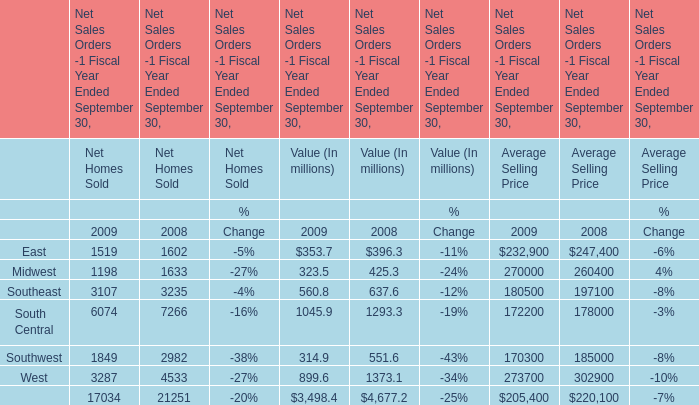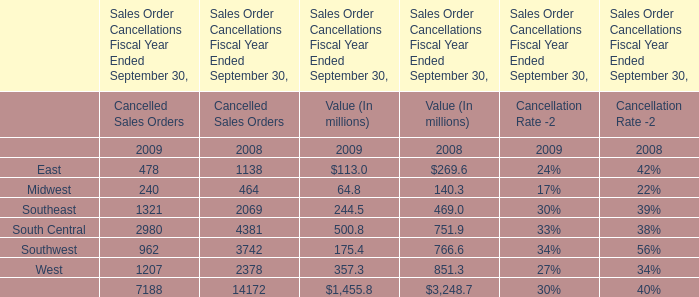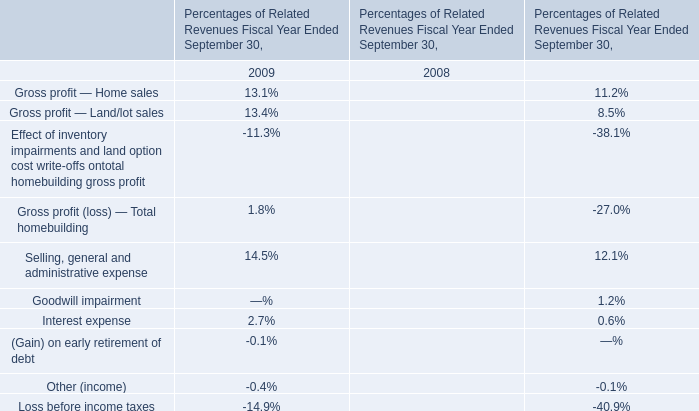What's the current growth rate of East for Net Homes Sold? 
Computations: ((1519 - 1602) / 1602)
Answer: -0.05181. 